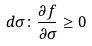<formula> <loc_0><loc_0><loc_500><loc_500>d \sigma \colon \frac { \partial f } { \partial \sigma } \geq 0</formula> 